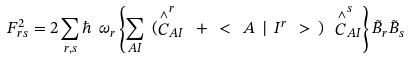Convert formula to latex. <formula><loc_0><loc_0><loc_500><loc_500>F _ { r s } ^ { 2 } = 2 \sum _ { r , s } \hbar { \ } \omega _ { r } \left \{ \sum _ { A I } \ ( \stackrel { \wedge } { C } _ { A I } ^ { r } \ + \ < \ A \ | \ I ^ { r } \ > \ ) \ \stackrel { \wedge } { C } _ { A I } ^ { s } \right \} \tilde { B } _ { r } \tilde { B } _ { s }</formula> 